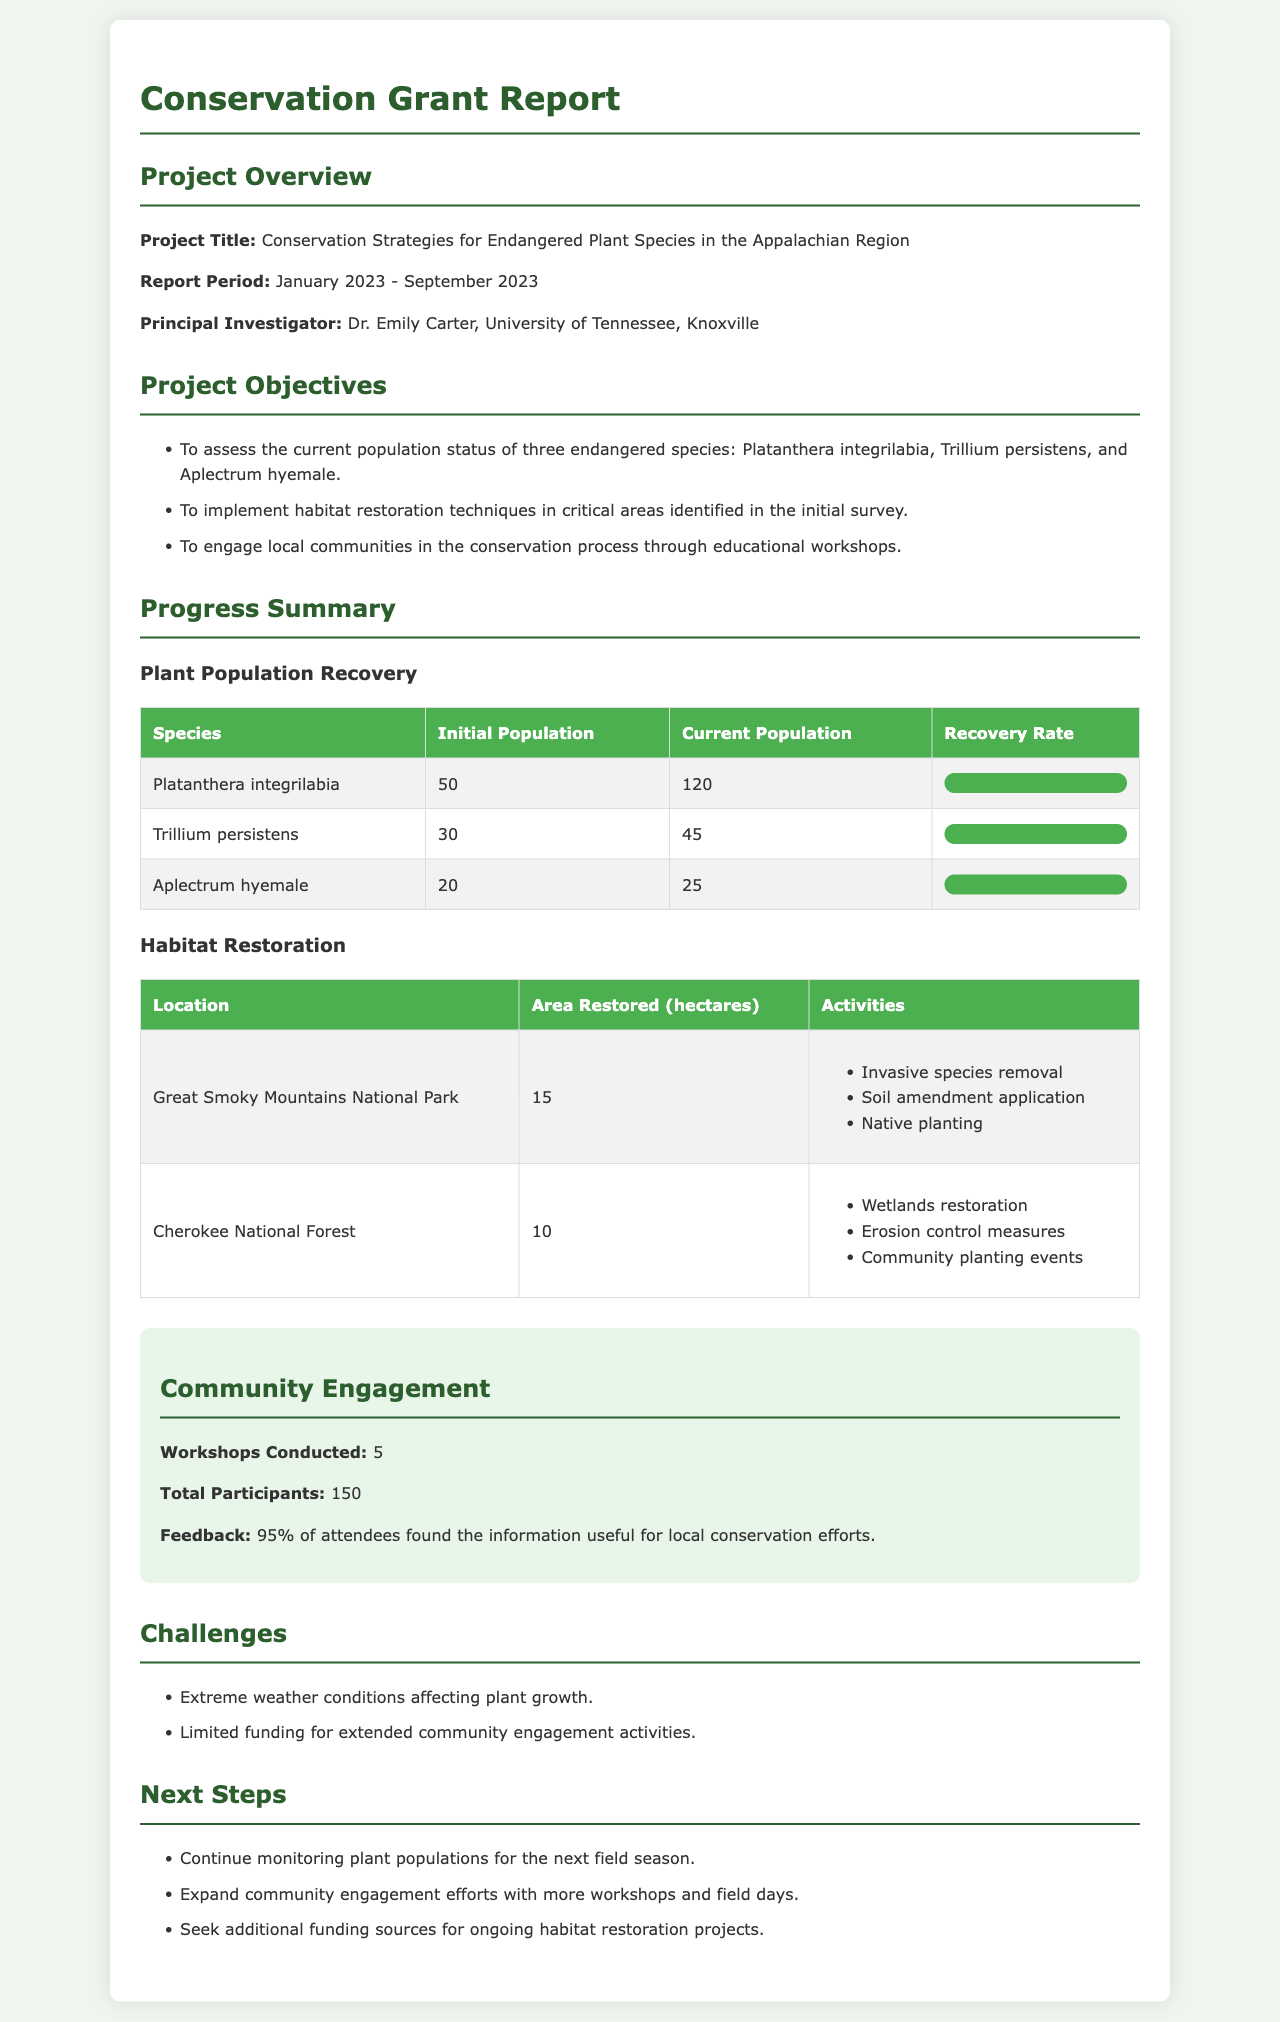What is the project title? The title of the project is mentioned in the Project Overview section.
Answer: Conservation Strategies for Endangered Plant Species in the Appalachian Region Who is the Principal Investigator? The name of the Principal Investigator is specified in the Project Overview section.
Answer: Dr. Emily Carter What is the report period? The report period details are provided in the Project Overview section.
Answer: January 2023 - September 2023 Which species has the highest recovery rate? The recovery rates of species are compared in the Plant Population Recovery table.
Answer: Trillium persistens How many hectares were restored in Cherokee National Forest? The area restored information is found in the Habitat Restoration table.
Answer: 10 What percentage of workshop attendees found the information useful? Feedback information is mentioned in the Community Engagement section.
Answer: 95% What are the next steps mentioned in the report? The next steps are listed in their own section, requiring detailed reading.
Answer: Continue monitoring plant populations for the next field season What challenge was reported regarding community engagement? This detail is included in the Challenges section outlining specific issues faced.
Answer: Limited funding for extended community engagement activities How many total participants attended the workshops? The total number of participants is specified in the Community Engagement section.
Answer: 150 